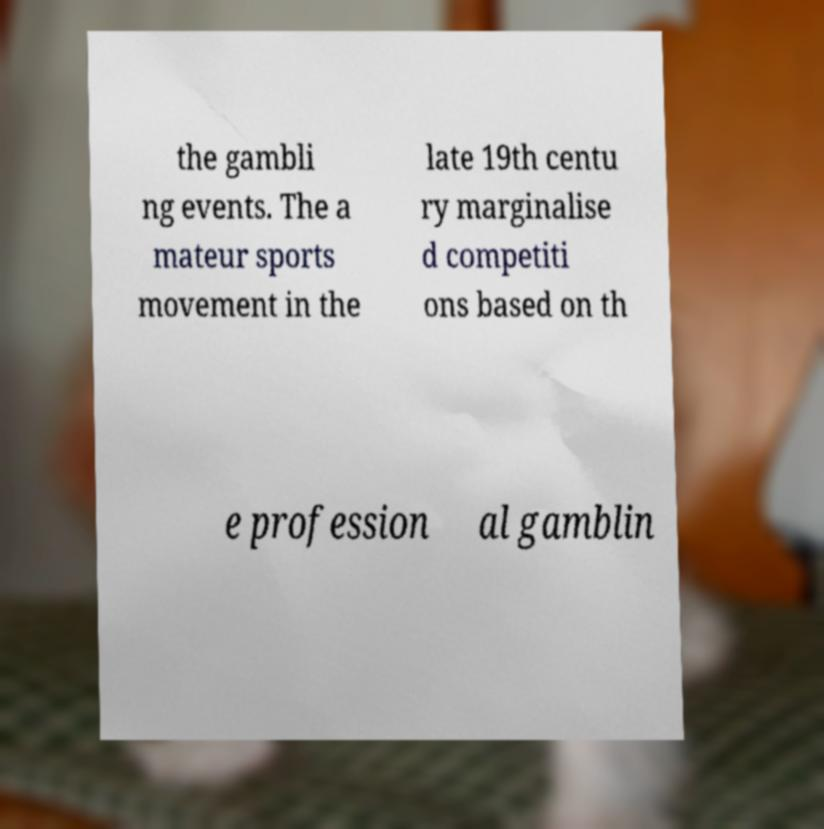What messages or text are displayed in this image? I need them in a readable, typed format. the gambli ng events. The a mateur sports movement in the late 19th centu ry marginalise d competiti ons based on th e profession al gamblin 